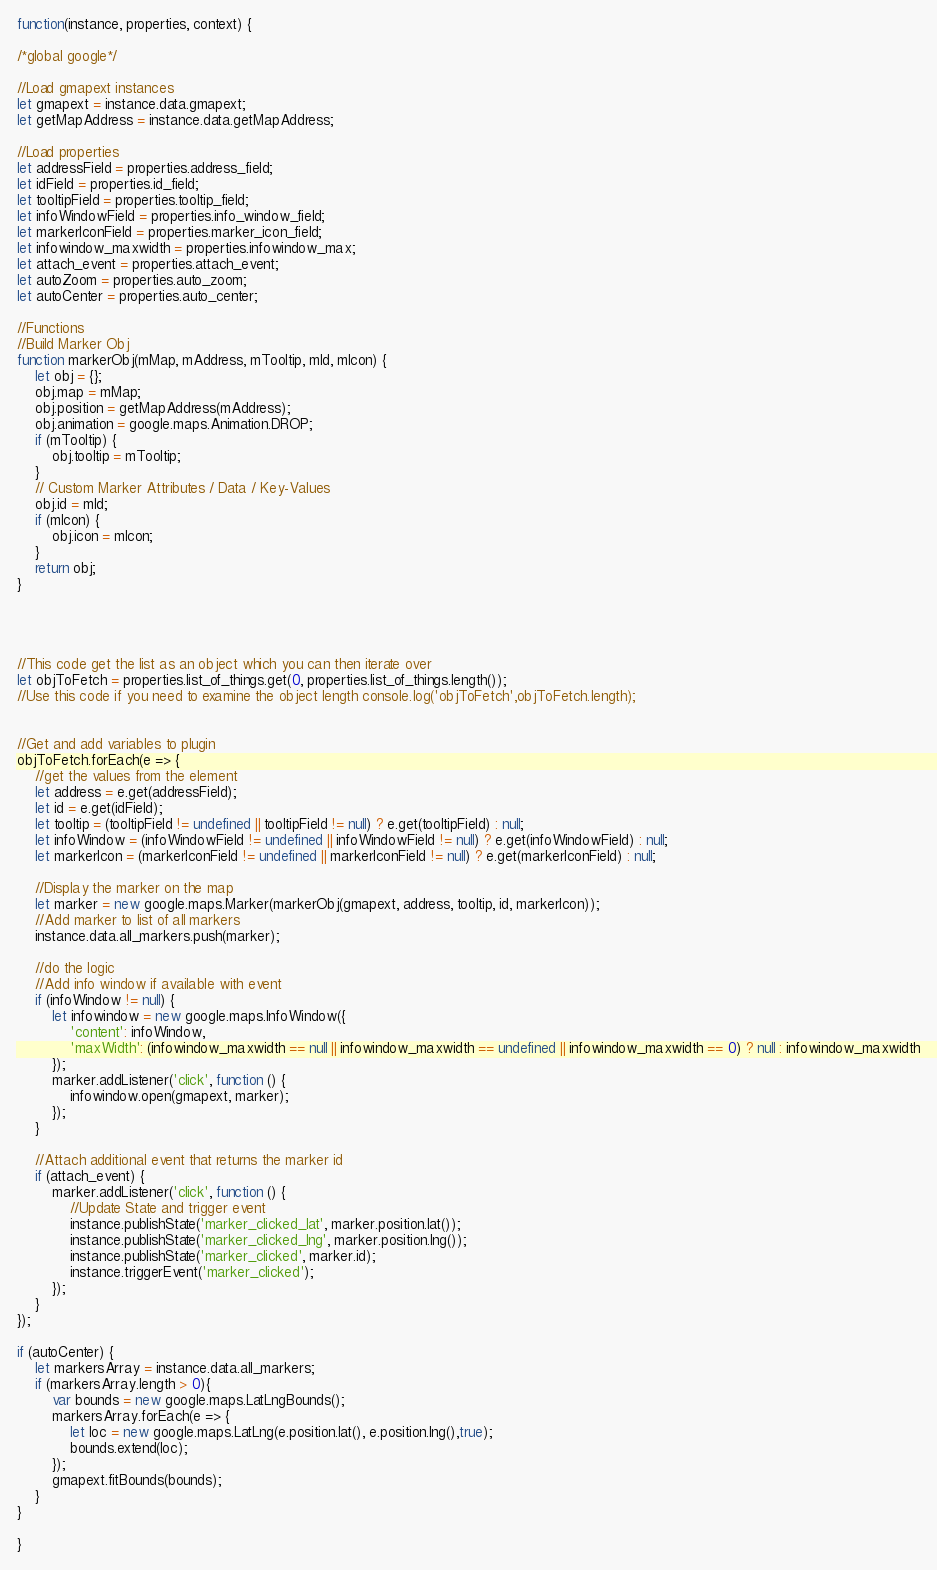Convert code to text. <code><loc_0><loc_0><loc_500><loc_500><_JavaScript_>function(instance, properties, context) {

/*global google*/

//Load gmapext instances
let gmapext = instance.data.gmapext;
let getMapAddress = instance.data.getMapAddress;

//Load properties
let addressField = properties.address_field;
let idField = properties.id_field;
let tooltipField = properties.tooltip_field;
let infoWindowField = properties.info_window_field;
let markerIconField = properties.marker_icon_field;
let infowindow_maxwidth = properties.infowindow_max;
let attach_event = properties.attach_event;
let autoZoom = properties.auto_zoom;
let autoCenter = properties.auto_center;

//Functions
//Build Marker Obj
function markerObj(mMap, mAddress, mTooltip, mId, mIcon) {
    let obj = {};
    obj.map = mMap;
    obj.position = getMapAddress(mAddress);
    obj.animation = google.maps.Animation.DROP;
    if (mTooltip) {
        obj.tooltip = mTooltip;
    }
    // Custom Marker Attributes / Data / Key-Values
    obj.id = mId;
    if (mIcon) {
        obj.icon = mIcon;
    }
    return obj;
}




//This code get the list as an object which you can then iterate over
let objToFetch = properties.list_of_things.get(0, properties.list_of_things.length());
//Use this code if you need to examine the object length console.log('objToFetch',objToFetch.length);


//Get and add variables to plugin
objToFetch.forEach(e => {
    //get the values from the element
    let address = e.get(addressField);
    let id = e.get(idField);
    let tooltip = (tooltipField != undefined || tooltipField != null) ? e.get(tooltipField) : null;
    let infoWindow = (infoWindowField != undefined || infoWindowField != null) ? e.get(infoWindowField) : null;
    let markerIcon = (markerIconField != undefined || markerIconField != null) ? e.get(markerIconField) : null;

    //Display the marker on the map
    let marker = new google.maps.Marker(markerObj(gmapext, address, tooltip, id, markerIcon));
    //Add marker to list of all markers
    instance.data.all_markers.push(marker);

    //do the logic
    //Add info window if available with event
    if (infoWindow != null) {
        let infowindow = new google.maps.InfoWindow({
            'content': infoWindow,
            'maxWidth': (infowindow_maxwidth == null || infowindow_maxwidth == undefined || infowindow_maxwidth == 0) ? null : infowindow_maxwidth
        });
        marker.addListener('click', function () {
            infowindow.open(gmapext, marker);
        });
    }

    //Attach additional event that returns the marker id
    if (attach_event) {
        marker.addListener('click', function () {
            //Update State and trigger event    
            instance.publishState('marker_clicked_lat', marker.position.lat());
            instance.publishState('marker_clicked_lng', marker.position.lng());
            instance.publishState('marker_clicked', marker.id);
            instance.triggerEvent('marker_clicked');
        });
    }
});

if (autoCenter) {
    let markersArray = instance.data.all_markers;
    if (markersArray.length > 0){
        var bounds = new google.maps.LatLngBounds();
        markersArray.forEach(e => {
            let loc = new google.maps.LatLng(e.position.lat(), e.position.lng(),true);
            bounds.extend(loc);
        });
        gmapext.fitBounds(bounds);
    }
}
    
}</code> 